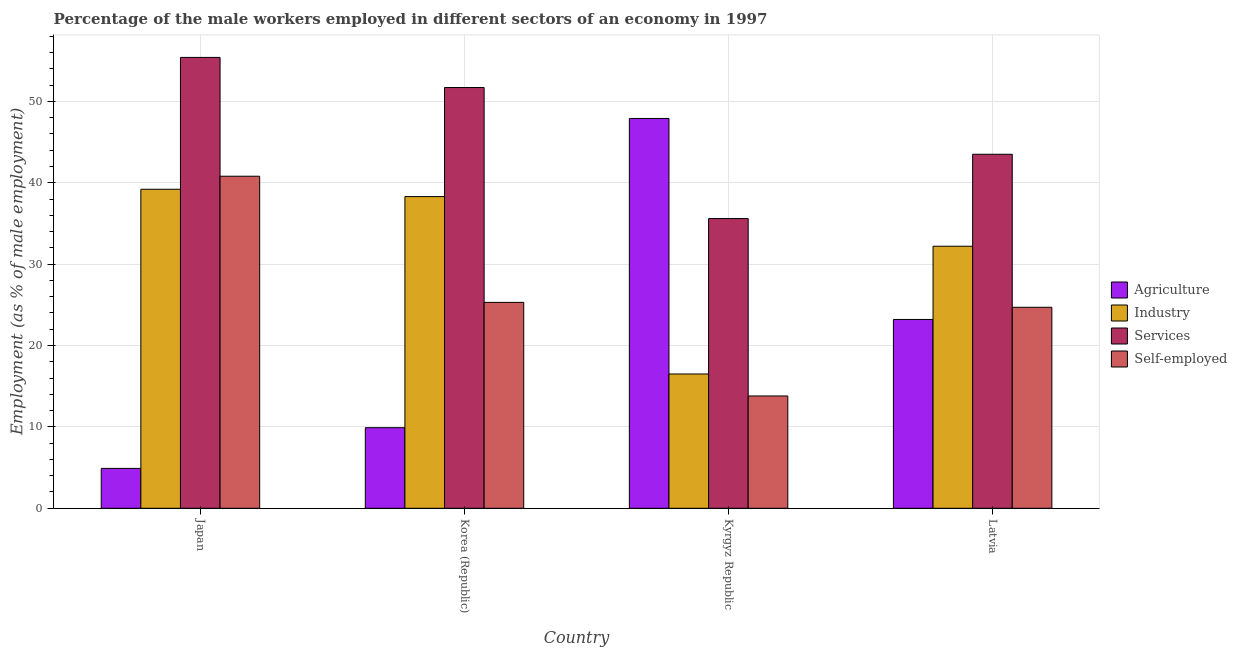How many different coloured bars are there?
Keep it short and to the point. 4. Are the number of bars per tick equal to the number of legend labels?
Your response must be concise. Yes. Are the number of bars on each tick of the X-axis equal?
Provide a short and direct response. Yes. How many bars are there on the 3rd tick from the right?
Your response must be concise. 4. In how many cases, is the number of bars for a given country not equal to the number of legend labels?
Ensure brevity in your answer.  0. Across all countries, what is the maximum percentage of male workers in industry?
Give a very brief answer. 39.2. Across all countries, what is the minimum percentage of male workers in agriculture?
Your answer should be compact. 4.9. In which country was the percentage of male workers in industry maximum?
Make the answer very short. Japan. In which country was the percentage of male workers in agriculture minimum?
Provide a short and direct response. Japan. What is the total percentage of male workers in agriculture in the graph?
Give a very brief answer. 85.9. What is the difference between the percentage of male workers in industry in Kyrgyz Republic and that in Latvia?
Your answer should be compact. -15.7. What is the difference between the percentage of male workers in industry in Kyrgyz Republic and the percentage of self employed male workers in Korea (Republic)?
Offer a terse response. -8.8. What is the average percentage of male workers in agriculture per country?
Your answer should be very brief. 21.48. What is the difference between the percentage of male workers in agriculture and percentage of male workers in services in Latvia?
Provide a short and direct response. -20.3. What is the ratio of the percentage of male workers in agriculture in Japan to that in Kyrgyz Republic?
Your response must be concise. 0.1. Is the difference between the percentage of self employed male workers in Japan and Kyrgyz Republic greater than the difference between the percentage of male workers in services in Japan and Kyrgyz Republic?
Provide a succinct answer. Yes. What is the difference between the highest and the second highest percentage of male workers in industry?
Your response must be concise. 0.9. What is the difference between the highest and the lowest percentage of male workers in services?
Your answer should be compact. 19.8. Is the sum of the percentage of male workers in services in Japan and Latvia greater than the maximum percentage of self employed male workers across all countries?
Provide a succinct answer. Yes. What does the 4th bar from the left in Korea (Republic) represents?
Give a very brief answer. Self-employed. What does the 4th bar from the right in Latvia represents?
Your answer should be compact. Agriculture. Is it the case that in every country, the sum of the percentage of male workers in agriculture and percentage of male workers in industry is greater than the percentage of male workers in services?
Your response must be concise. No. How many bars are there?
Ensure brevity in your answer.  16. How many countries are there in the graph?
Offer a very short reply. 4. Are the values on the major ticks of Y-axis written in scientific E-notation?
Offer a very short reply. No. Does the graph contain grids?
Ensure brevity in your answer.  Yes. How are the legend labels stacked?
Give a very brief answer. Vertical. What is the title of the graph?
Give a very brief answer. Percentage of the male workers employed in different sectors of an economy in 1997. Does "Rule based governance" appear as one of the legend labels in the graph?
Ensure brevity in your answer.  No. What is the label or title of the Y-axis?
Give a very brief answer. Employment (as % of male employment). What is the Employment (as % of male employment) of Agriculture in Japan?
Make the answer very short. 4.9. What is the Employment (as % of male employment) in Industry in Japan?
Ensure brevity in your answer.  39.2. What is the Employment (as % of male employment) in Services in Japan?
Keep it short and to the point. 55.4. What is the Employment (as % of male employment) in Self-employed in Japan?
Give a very brief answer. 40.8. What is the Employment (as % of male employment) in Agriculture in Korea (Republic)?
Give a very brief answer. 9.9. What is the Employment (as % of male employment) of Industry in Korea (Republic)?
Make the answer very short. 38.3. What is the Employment (as % of male employment) of Services in Korea (Republic)?
Provide a short and direct response. 51.7. What is the Employment (as % of male employment) in Self-employed in Korea (Republic)?
Offer a very short reply. 25.3. What is the Employment (as % of male employment) in Agriculture in Kyrgyz Republic?
Keep it short and to the point. 47.9. What is the Employment (as % of male employment) in Industry in Kyrgyz Republic?
Your response must be concise. 16.5. What is the Employment (as % of male employment) in Services in Kyrgyz Republic?
Provide a short and direct response. 35.6. What is the Employment (as % of male employment) in Self-employed in Kyrgyz Republic?
Provide a short and direct response. 13.8. What is the Employment (as % of male employment) in Agriculture in Latvia?
Offer a terse response. 23.2. What is the Employment (as % of male employment) in Industry in Latvia?
Provide a short and direct response. 32.2. What is the Employment (as % of male employment) of Services in Latvia?
Provide a short and direct response. 43.5. What is the Employment (as % of male employment) in Self-employed in Latvia?
Offer a very short reply. 24.7. Across all countries, what is the maximum Employment (as % of male employment) in Agriculture?
Offer a terse response. 47.9. Across all countries, what is the maximum Employment (as % of male employment) of Industry?
Ensure brevity in your answer.  39.2. Across all countries, what is the maximum Employment (as % of male employment) in Services?
Ensure brevity in your answer.  55.4. Across all countries, what is the maximum Employment (as % of male employment) of Self-employed?
Provide a succinct answer. 40.8. Across all countries, what is the minimum Employment (as % of male employment) in Agriculture?
Offer a terse response. 4.9. Across all countries, what is the minimum Employment (as % of male employment) in Services?
Your answer should be compact. 35.6. Across all countries, what is the minimum Employment (as % of male employment) of Self-employed?
Your answer should be very brief. 13.8. What is the total Employment (as % of male employment) in Agriculture in the graph?
Ensure brevity in your answer.  85.9. What is the total Employment (as % of male employment) of Industry in the graph?
Offer a terse response. 126.2. What is the total Employment (as % of male employment) in Services in the graph?
Keep it short and to the point. 186.2. What is the total Employment (as % of male employment) in Self-employed in the graph?
Give a very brief answer. 104.6. What is the difference between the Employment (as % of male employment) in Agriculture in Japan and that in Kyrgyz Republic?
Ensure brevity in your answer.  -43. What is the difference between the Employment (as % of male employment) in Industry in Japan and that in Kyrgyz Republic?
Offer a very short reply. 22.7. What is the difference between the Employment (as % of male employment) in Services in Japan and that in Kyrgyz Republic?
Provide a succinct answer. 19.8. What is the difference between the Employment (as % of male employment) of Self-employed in Japan and that in Kyrgyz Republic?
Give a very brief answer. 27. What is the difference between the Employment (as % of male employment) of Agriculture in Japan and that in Latvia?
Ensure brevity in your answer.  -18.3. What is the difference between the Employment (as % of male employment) in Self-employed in Japan and that in Latvia?
Offer a terse response. 16.1. What is the difference between the Employment (as % of male employment) in Agriculture in Korea (Republic) and that in Kyrgyz Republic?
Ensure brevity in your answer.  -38. What is the difference between the Employment (as % of male employment) of Industry in Korea (Republic) and that in Kyrgyz Republic?
Offer a terse response. 21.8. What is the difference between the Employment (as % of male employment) in Self-employed in Korea (Republic) and that in Kyrgyz Republic?
Provide a short and direct response. 11.5. What is the difference between the Employment (as % of male employment) of Agriculture in Korea (Republic) and that in Latvia?
Keep it short and to the point. -13.3. What is the difference between the Employment (as % of male employment) of Services in Korea (Republic) and that in Latvia?
Offer a very short reply. 8.2. What is the difference between the Employment (as % of male employment) in Agriculture in Kyrgyz Republic and that in Latvia?
Ensure brevity in your answer.  24.7. What is the difference between the Employment (as % of male employment) in Industry in Kyrgyz Republic and that in Latvia?
Your answer should be compact. -15.7. What is the difference between the Employment (as % of male employment) in Self-employed in Kyrgyz Republic and that in Latvia?
Your answer should be very brief. -10.9. What is the difference between the Employment (as % of male employment) of Agriculture in Japan and the Employment (as % of male employment) of Industry in Korea (Republic)?
Keep it short and to the point. -33.4. What is the difference between the Employment (as % of male employment) of Agriculture in Japan and the Employment (as % of male employment) of Services in Korea (Republic)?
Provide a short and direct response. -46.8. What is the difference between the Employment (as % of male employment) of Agriculture in Japan and the Employment (as % of male employment) of Self-employed in Korea (Republic)?
Your answer should be very brief. -20.4. What is the difference between the Employment (as % of male employment) in Industry in Japan and the Employment (as % of male employment) in Self-employed in Korea (Republic)?
Ensure brevity in your answer.  13.9. What is the difference between the Employment (as % of male employment) in Services in Japan and the Employment (as % of male employment) in Self-employed in Korea (Republic)?
Offer a terse response. 30.1. What is the difference between the Employment (as % of male employment) in Agriculture in Japan and the Employment (as % of male employment) in Industry in Kyrgyz Republic?
Your answer should be compact. -11.6. What is the difference between the Employment (as % of male employment) of Agriculture in Japan and the Employment (as % of male employment) of Services in Kyrgyz Republic?
Offer a terse response. -30.7. What is the difference between the Employment (as % of male employment) of Industry in Japan and the Employment (as % of male employment) of Self-employed in Kyrgyz Republic?
Provide a short and direct response. 25.4. What is the difference between the Employment (as % of male employment) of Services in Japan and the Employment (as % of male employment) of Self-employed in Kyrgyz Republic?
Your answer should be very brief. 41.6. What is the difference between the Employment (as % of male employment) in Agriculture in Japan and the Employment (as % of male employment) in Industry in Latvia?
Keep it short and to the point. -27.3. What is the difference between the Employment (as % of male employment) of Agriculture in Japan and the Employment (as % of male employment) of Services in Latvia?
Your answer should be compact. -38.6. What is the difference between the Employment (as % of male employment) of Agriculture in Japan and the Employment (as % of male employment) of Self-employed in Latvia?
Offer a terse response. -19.8. What is the difference between the Employment (as % of male employment) of Industry in Japan and the Employment (as % of male employment) of Services in Latvia?
Offer a very short reply. -4.3. What is the difference between the Employment (as % of male employment) in Industry in Japan and the Employment (as % of male employment) in Self-employed in Latvia?
Keep it short and to the point. 14.5. What is the difference between the Employment (as % of male employment) in Services in Japan and the Employment (as % of male employment) in Self-employed in Latvia?
Offer a terse response. 30.7. What is the difference between the Employment (as % of male employment) of Agriculture in Korea (Republic) and the Employment (as % of male employment) of Services in Kyrgyz Republic?
Your answer should be very brief. -25.7. What is the difference between the Employment (as % of male employment) of Agriculture in Korea (Republic) and the Employment (as % of male employment) of Self-employed in Kyrgyz Republic?
Your answer should be compact. -3.9. What is the difference between the Employment (as % of male employment) of Industry in Korea (Republic) and the Employment (as % of male employment) of Self-employed in Kyrgyz Republic?
Your answer should be compact. 24.5. What is the difference between the Employment (as % of male employment) of Services in Korea (Republic) and the Employment (as % of male employment) of Self-employed in Kyrgyz Republic?
Provide a short and direct response. 37.9. What is the difference between the Employment (as % of male employment) of Agriculture in Korea (Republic) and the Employment (as % of male employment) of Industry in Latvia?
Your answer should be compact. -22.3. What is the difference between the Employment (as % of male employment) in Agriculture in Korea (Republic) and the Employment (as % of male employment) in Services in Latvia?
Your response must be concise. -33.6. What is the difference between the Employment (as % of male employment) of Agriculture in Korea (Republic) and the Employment (as % of male employment) of Self-employed in Latvia?
Provide a succinct answer. -14.8. What is the difference between the Employment (as % of male employment) of Industry in Korea (Republic) and the Employment (as % of male employment) of Services in Latvia?
Provide a short and direct response. -5.2. What is the difference between the Employment (as % of male employment) of Services in Korea (Republic) and the Employment (as % of male employment) of Self-employed in Latvia?
Offer a terse response. 27. What is the difference between the Employment (as % of male employment) in Agriculture in Kyrgyz Republic and the Employment (as % of male employment) in Industry in Latvia?
Ensure brevity in your answer.  15.7. What is the difference between the Employment (as % of male employment) of Agriculture in Kyrgyz Republic and the Employment (as % of male employment) of Services in Latvia?
Keep it short and to the point. 4.4. What is the difference between the Employment (as % of male employment) of Agriculture in Kyrgyz Republic and the Employment (as % of male employment) of Self-employed in Latvia?
Offer a terse response. 23.2. What is the difference between the Employment (as % of male employment) in Industry in Kyrgyz Republic and the Employment (as % of male employment) in Self-employed in Latvia?
Your answer should be compact. -8.2. What is the average Employment (as % of male employment) of Agriculture per country?
Offer a very short reply. 21.48. What is the average Employment (as % of male employment) in Industry per country?
Keep it short and to the point. 31.55. What is the average Employment (as % of male employment) in Services per country?
Provide a short and direct response. 46.55. What is the average Employment (as % of male employment) in Self-employed per country?
Your response must be concise. 26.15. What is the difference between the Employment (as % of male employment) in Agriculture and Employment (as % of male employment) in Industry in Japan?
Keep it short and to the point. -34.3. What is the difference between the Employment (as % of male employment) of Agriculture and Employment (as % of male employment) of Services in Japan?
Offer a terse response. -50.5. What is the difference between the Employment (as % of male employment) in Agriculture and Employment (as % of male employment) in Self-employed in Japan?
Make the answer very short. -35.9. What is the difference between the Employment (as % of male employment) of Industry and Employment (as % of male employment) of Services in Japan?
Keep it short and to the point. -16.2. What is the difference between the Employment (as % of male employment) of Agriculture and Employment (as % of male employment) of Industry in Korea (Republic)?
Ensure brevity in your answer.  -28.4. What is the difference between the Employment (as % of male employment) of Agriculture and Employment (as % of male employment) of Services in Korea (Republic)?
Make the answer very short. -41.8. What is the difference between the Employment (as % of male employment) in Agriculture and Employment (as % of male employment) in Self-employed in Korea (Republic)?
Provide a short and direct response. -15.4. What is the difference between the Employment (as % of male employment) of Industry and Employment (as % of male employment) of Services in Korea (Republic)?
Your response must be concise. -13.4. What is the difference between the Employment (as % of male employment) in Industry and Employment (as % of male employment) in Self-employed in Korea (Republic)?
Offer a terse response. 13. What is the difference between the Employment (as % of male employment) of Services and Employment (as % of male employment) of Self-employed in Korea (Republic)?
Keep it short and to the point. 26.4. What is the difference between the Employment (as % of male employment) of Agriculture and Employment (as % of male employment) of Industry in Kyrgyz Republic?
Offer a terse response. 31.4. What is the difference between the Employment (as % of male employment) of Agriculture and Employment (as % of male employment) of Services in Kyrgyz Republic?
Keep it short and to the point. 12.3. What is the difference between the Employment (as % of male employment) of Agriculture and Employment (as % of male employment) of Self-employed in Kyrgyz Republic?
Provide a succinct answer. 34.1. What is the difference between the Employment (as % of male employment) in Industry and Employment (as % of male employment) in Services in Kyrgyz Republic?
Offer a terse response. -19.1. What is the difference between the Employment (as % of male employment) in Industry and Employment (as % of male employment) in Self-employed in Kyrgyz Republic?
Keep it short and to the point. 2.7. What is the difference between the Employment (as % of male employment) in Services and Employment (as % of male employment) in Self-employed in Kyrgyz Republic?
Offer a terse response. 21.8. What is the difference between the Employment (as % of male employment) in Agriculture and Employment (as % of male employment) in Industry in Latvia?
Your answer should be compact. -9. What is the difference between the Employment (as % of male employment) of Agriculture and Employment (as % of male employment) of Services in Latvia?
Ensure brevity in your answer.  -20.3. What is the difference between the Employment (as % of male employment) in Industry and Employment (as % of male employment) in Services in Latvia?
Provide a short and direct response. -11.3. What is the difference between the Employment (as % of male employment) in Industry and Employment (as % of male employment) in Self-employed in Latvia?
Make the answer very short. 7.5. What is the difference between the Employment (as % of male employment) of Services and Employment (as % of male employment) of Self-employed in Latvia?
Provide a short and direct response. 18.8. What is the ratio of the Employment (as % of male employment) in Agriculture in Japan to that in Korea (Republic)?
Provide a succinct answer. 0.49. What is the ratio of the Employment (as % of male employment) in Industry in Japan to that in Korea (Republic)?
Your answer should be very brief. 1.02. What is the ratio of the Employment (as % of male employment) in Services in Japan to that in Korea (Republic)?
Make the answer very short. 1.07. What is the ratio of the Employment (as % of male employment) in Self-employed in Japan to that in Korea (Republic)?
Provide a succinct answer. 1.61. What is the ratio of the Employment (as % of male employment) in Agriculture in Japan to that in Kyrgyz Republic?
Provide a short and direct response. 0.1. What is the ratio of the Employment (as % of male employment) in Industry in Japan to that in Kyrgyz Republic?
Provide a short and direct response. 2.38. What is the ratio of the Employment (as % of male employment) in Services in Japan to that in Kyrgyz Republic?
Provide a succinct answer. 1.56. What is the ratio of the Employment (as % of male employment) of Self-employed in Japan to that in Kyrgyz Republic?
Offer a very short reply. 2.96. What is the ratio of the Employment (as % of male employment) of Agriculture in Japan to that in Latvia?
Offer a very short reply. 0.21. What is the ratio of the Employment (as % of male employment) of Industry in Japan to that in Latvia?
Provide a short and direct response. 1.22. What is the ratio of the Employment (as % of male employment) in Services in Japan to that in Latvia?
Offer a terse response. 1.27. What is the ratio of the Employment (as % of male employment) of Self-employed in Japan to that in Latvia?
Your answer should be compact. 1.65. What is the ratio of the Employment (as % of male employment) of Agriculture in Korea (Republic) to that in Kyrgyz Republic?
Keep it short and to the point. 0.21. What is the ratio of the Employment (as % of male employment) in Industry in Korea (Republic) to that in Kyrgyz Republic?
Provide a short and direct response. 2.32. What is the ratio of the Employment (as % of male employment) of Services in Korea (Republic) to that in Kyrgyz Republic?
Your response must be concise. 1.45. What is the ratio of the Employment (as % of male employment) of Self-employed in Korea (Republic) to that in Kyrgyz Republic?
Make the answer very short. 1.83. What is the ratio of the Employment (as % of male employment) in Agriculture in Korea (Republic) to that in Latvia?
Give a very brief answer. 0.43. What is the ratio of the Employment (as % of male employment) of Industry in Korea (Republic) to that in Latvia?
Your response must be concise. 1.19. What is the ratio of the Employment (as % of male employment) in Services in Korea (Republic) to that in Latvia?
Give a very brief answer. 1.19. What is the ratio of the Employment (as % of male employment) of Self-employed in Korea (Republic) to that in Latvia?
Make the answer very short. 1.02. What is the ratio of the Employment (as % of male employment) in Agriculture in Kyrgyz Republic to that in Latvia?
Your answer should be compact. 2.06. What is the ratio of the Employment (as % of male employment) of Industry in Kyrgyz Republic to that in Latvia?
Your response must be concise. 0.51. What is the ratio of the Employment (as % of male employment) of Services in Kyrgyz Republic to that in Latvia?
Your response must be concise. 0.82. What is the ratio of the Employment (as % of male employment) in Self-employed in Kyrgyz Republic to that in Latvia?
Offer a very short reply. 0.56. What is the difference between the highest and the second highest Employment (as % of male employment) of Agriculture?
Provide a succinct answer. 24.7. What is the difference between the highest and the second highest Employment (as % of male employment) in Industry?
Keep it short and to the point. 0.9. What is the difference between the highest and the second highest Employment (as % of male employment) in Services?
Give a very brief answer. 3.7. What is the difference between the highest and the lowest Employment (as % of male employment) of Agriculture?
Offer a terse response. 43. What is the difference between the highest and the lowest Employment (as % of male employment) of Industry?
Offer a very short reply. 22.7. What is the difference between the highest and the lowest Employment (as % of male employment) in Services?
Your answer should be very brief. 19.8. What is the difference between the highest and the lowest Employment (as % of male employment) in Self-employed?
Your answer should be very brief. 27. 